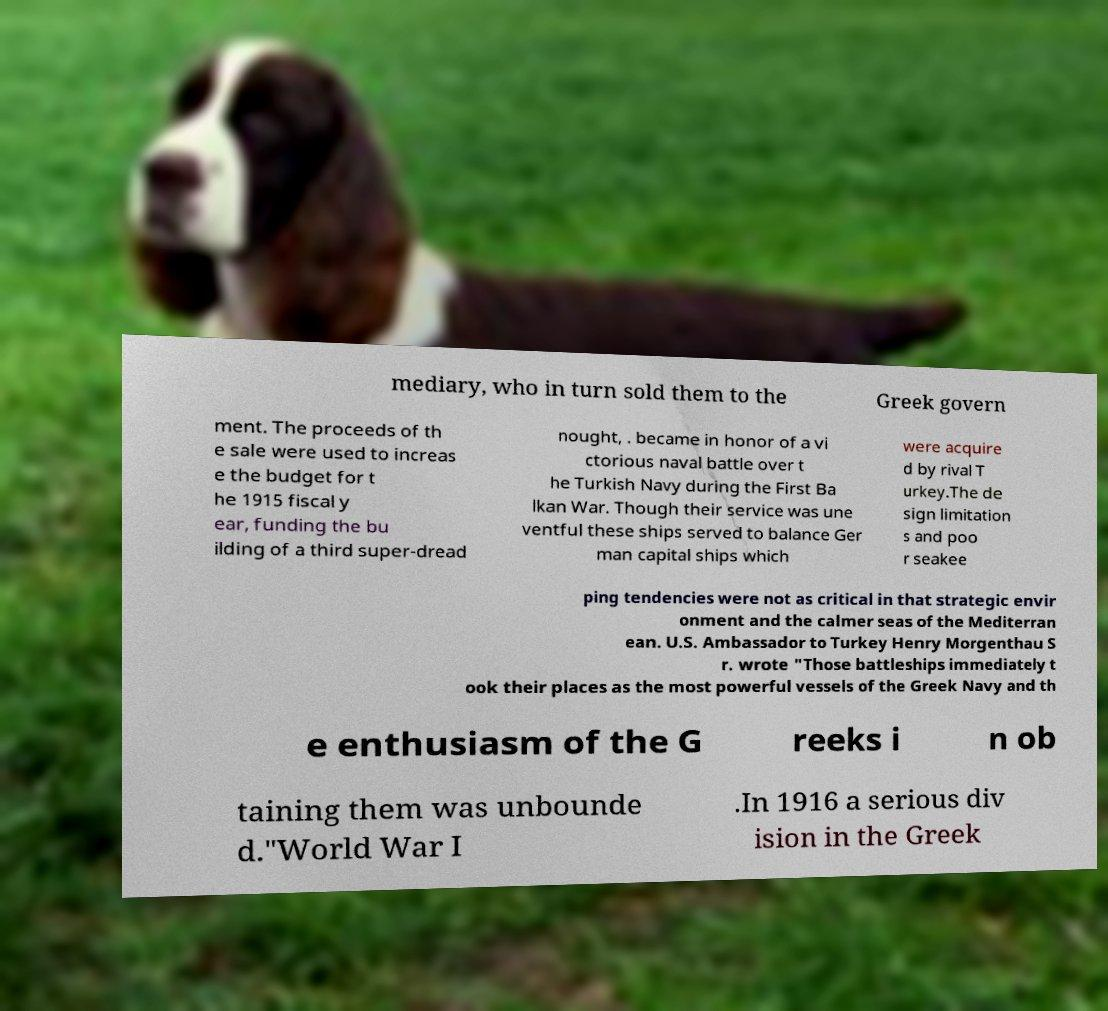I need the written content from this picture converted into text. Can you do that? mediary, who in turn sold them to the Greek govern ment. The proceeds of th e sale were used to increas e the budget for t he 1915 fiscal y ear, funding the bu ilding of a third super-dread nought, . became in honor of a vi ctorious naval battle over t he Turkish Navy during the First Ba lkan War. Though their service was une ventful these ships served to balance Ger man capital ships which were acquire d by rival T urkey.The de sign limitation s and poo r seakee ping tendencies were not as critical in that strategic envir onment and the calmer seas of the Mediterran ean. U.S. Ambassador to Turkey Henry Morgenthau S r. wrote "Those battleships immediately t ook their places as the most powerful vessels of the Greek Navy and th e enthusiasm of the G reeks i n ob taining them was unbounde d."World War I .In 1916 a serious div ision in the Greek 